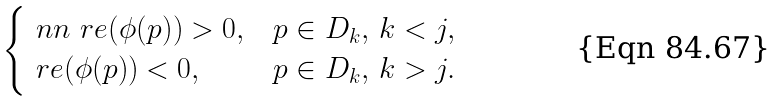Convert formula to latex. <formula><loc_0><loc_0><loc_500><loc_500>\begin{cases} \ n n \ r e ( \phi ( p ) ) > 0 , & p \in D _ { k } , \, k < j , \\ \ r e ( \phi ( p ) ) < 0 , & p \in D _ { k } , \, k > j . \end{cases}</formula> 